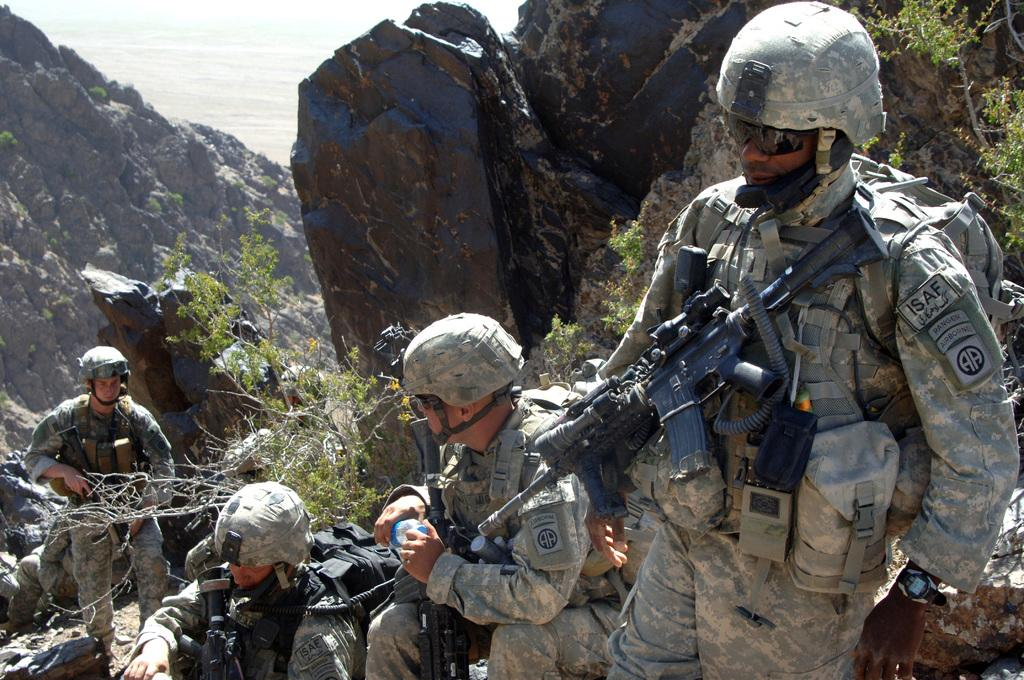What type of people can be seen in the image? There are soldiers in the image. Where are the soldiers positioned in the image? The soldiers are between rocks. What are the soldiers holding in the image? The soldiers are holding weapons. What natural element can be seen in the image? There is water visible in the image. What type of vegetation is present in the image? There are plants in the image. What is the most popular attraction in the image? There is no attraction present in the image; it features soldiers between rocks, holding weapons, with water and plants visible. How hot is the water in the image? The temperature of the water in the image cannot be determined from the image itself. 